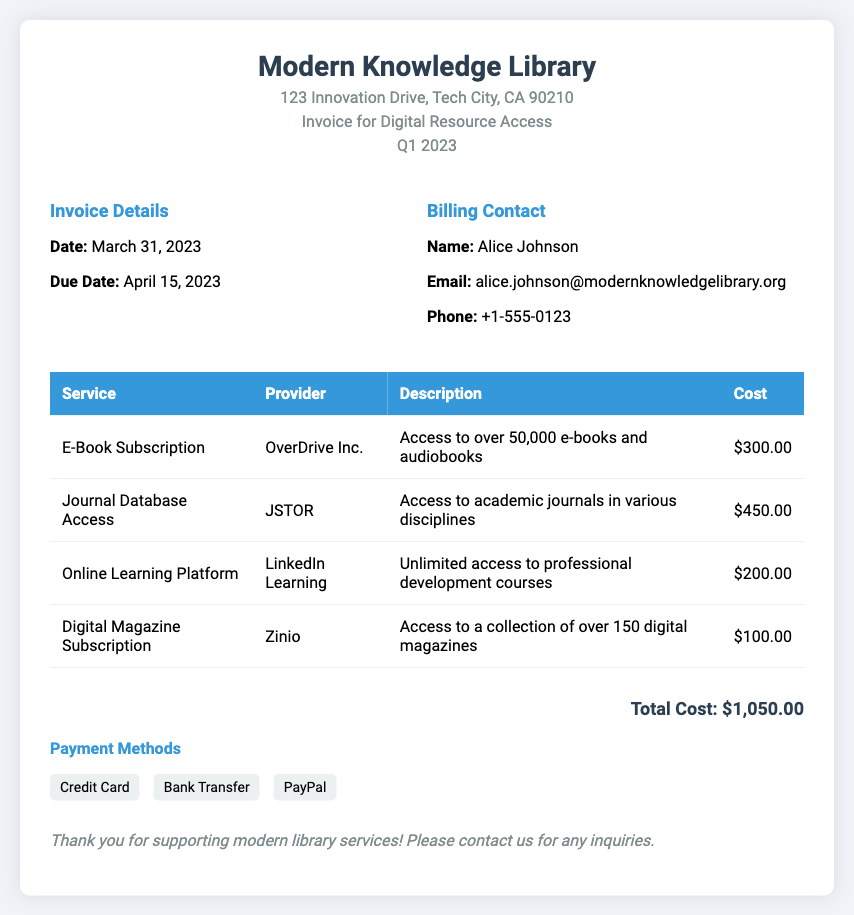What is the total cost? The total cost is listed at the bottom of the invoice, which sums up all the individual services.
Answer: $1,050.00 Who is the billing contact? The billing contact's name is provided in the invoice details section.
Answer: Alice Johnson What is the due date for the invoice? The due date is indicated in the invoice details section.
Answer: April 15, 2023 How many e-books and audiobooks can be accessed? The description for the e-book subscription specifies the number of items available.
Answer: over 50,000 Which company provides the Online Learning Platform? The service provider for the Online Learning Platform is mentioned in the table.
Answer: LinkedIn Learning What type of payment methods are accepted? The invoice includes a list of payment methods available at the bottom.
Answer: Credit Card, Bank Transfer, PayPal What service costs $450.00? The cost of $450.00 is associated with a specific service provided in the invoice.
Answer: Journal Database Access What is the address of the library? The library's address is provided in the header of the invoice.
Answer: 123 Innovation Drive, Tech City, CA 90210 What is the date of the invoice? The invoice date is specified clearly in the invoice details section.
Answer: March 31, 2023 